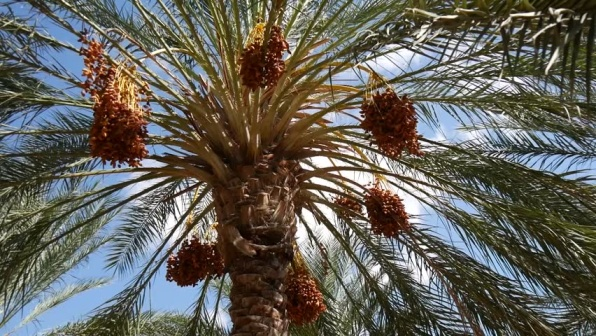What is this photo about? The image showcases a robust palm tree under a brilliantly clear blue sky. The tree's thick, textured trunk supports numerous fronds that burst with lush, vivid green leaves. Interspersed among these leaves are striking clusters of dates, their rich orange-red hues vivid against the green backdrop. These fruits are not merely beautiful; they are also a vital food source in many cultures, often celebrated for their nutritional value and historical significance in Middle Eastern and North African regions. This scene is not only a portrayal of natural beauty but also reflects the ecological and cultural roles of the palm tree. 